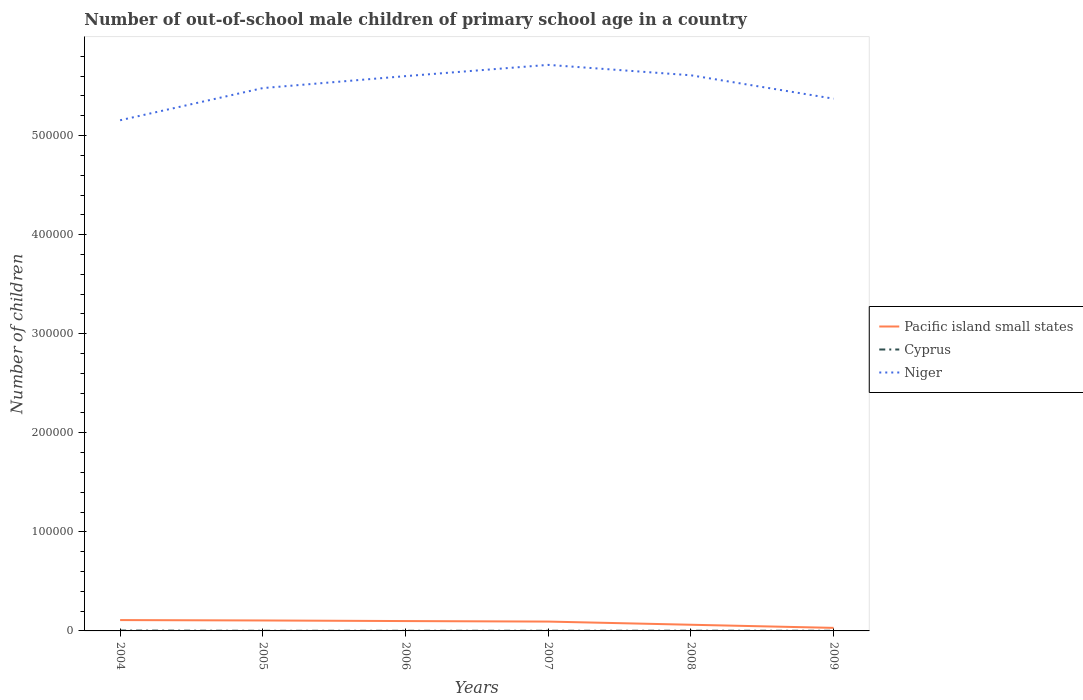Is the number of lines equal to the number of legend labels?
Offer a very short reply. Yes. Across all years, what is the maximum number of out-of-school male children in Pacific island small states?
Your answer should be very brief. 3078. What is the total number of out-of-school male children in Pacific island small states in the graph?
Offer a terse response. 3725. What is the difference between the highest and the second highest number of out-of-school male children in Pacific island small states?
Offer a terse response. 7874. How many years are there in the graph?
Your answer should be compact. 6. What is the difference between two consecutive major ticks on the Y-axis?
Offer a terse response. 1.00e+05. Are the values on the major ticks of Y-axis written in scientific E-notation?
Provide a short and direct response. No. Does the graph contain any zero values?
Keep it short and to the point. No. Does the graph contain grids?
Ensure brevity in your answer.  No. What is the title of the graph?
Make the answer very short. Number of out-of-school male children of primary school age in a country. What is the label or title of the Y-axis?
Offer a very short reply. Number of children. What is the Number of children of Pacific island small states in 2004?
Ensure brevity in your answer.  1.10e+04. What is the Number of children of Cyprus in 2004?
Your answer should be very brief. 380. What is the Number of children in Niger in 2004?
Make the answer very short. 5.16e+05. What is the Number of children in Pacific island small states in 2005?
Keep it short and to the point. 1.05e+04. What is the Number of children in Cyprus in 2005?
Keep it short and to the point. 130. What is the Number of children in Niger in 2005?
Keep it short and to the point. 5.48e+05. What is the Number of children in Pacific island small states in 2006?
Make the answer very short. 9948. What is the Number of children of Cyprus in 2006?
Provide a short and direct response. 142. What is the Number of children of Niger in 2006?
Provide a short and direct response. 5.60e+05. What is the Number of children of Pacific island small states in 2007?
Give a very brief answer. 9438. What is the Number of children in Cyprus in 2007?
Offer a very short reply. 163. What is the Number of children of Niger in 2007?
Your answer should be compact. 5.71e+05. What is the Number of children in Pacific island small states in 2008?
Your answer should be very brief. 6223. What is the Number of children of Cyprus in 2008?
Your answer should be compact. 212. What is the Number of children of Niger in 2008?
Your response must be concise. 5.61e+05. What is the Number of children of Pacific island small states in 2009?
Your response must be concise. 3078. What is the Number of children in Cyprus in 2009?
Ensure brevity in your answer.  155. What is the Number of children of Niger in 2009?
Your response must be concise. 5.37e+05. Across all years, what is the maximum Number of children in Pacific island small states?
Keep it short and to the point. 1.10e+04. Across all years, what is the maximum Number of children in Cyprus?
Give a very brief answer. 380. Across all years, what is the maximum Number of children in Niger?
Offer a very short reply. 5.71e+05. Across all years, what is the minimum Number of children of Pacific island small states?
Your answer should be compact. 3078. Across all years, what is the minimum Number of children in Cyprus?
Your answer should be very brief. 130. Across all years, what is the minimum Number of children of Niger?
Your response must be concise. 5.16e+05. What is the total Number of children in Pacific island small states in the graph?
Make the answer very short. 5.02e+04. What is the total Number of children in Cyprus in the graph?
Give a very brief answer. 1182. What is the total Number of children in Niger in the graph?
Keep it short and to the point. 3.29e+06. What is the difference between the Number of children in Pacific island small states in 2004 and that in 2005?
Keep it short and to the point. 407. What is the difference between the Number of children of Cyprus in 2004 and that in 2005?
Ensure brevity in your answer.  250. What is the difference between the Number of children in Niger in 2004 and that in 2005?
Your answer should be compact. -3.25e+04. What is the difference between the Number of children of Pacific island small states in 2004 and that in 2006?
Ensure brevity in your answer.  1004. What is the difference between the Number of children in Cyprus in 2004 and that in 2006?
Offer a terse response. 238. What is the difference between the Number of children of Niger in 2004 and that in 2006?
Provide a succinct answer. -4.45e+04. What is the difference between the Number of children of Pacific island small states in 2004 and that in 2007?
Ensure brevity in your answer.  1514. What is the difference between the Number of children of Cyprus in 2004 and that in 2007?
Provide a short and direct response. 217. What is the difference between the Number of children of Niger in 2004 and that in 2007?
Ensure brevity in your answer.  -5.59e+04. What is the difference between the Number of children of Pacific island small states in 2004 and that in 2008?
Provide a short and direct response. 4729. What is the difference between the Number of children in Cyprus in 2004 and that in 2008?
Your response must be concise. 168. What is the difference between the Number of children in Niger in 2004 and that in 2008?
Provide a succinct answer. -4.54e+04. What is the difference between the Number of children of Pacific island small states in 2004 and that in 2009?
Your response must be concise. 7874. What is the difference between the Number of children of Cyprus in 2004 and that in 2009?
Keep it short and to the point. 225. What is the difference between the Number of children of Niger in 2004 and that in 2009?
Make the answer very short. -2.18e+04. What is the difference between the Number of children in Pacific island small states in 2005 and that in 2006?
Keep it short and to the point. 597. What is the difference between the Number of children of Cyprus in 2005 and that in 2006?
Provide a succinct answer. -12. What is the difference between the Number of children in Niger in 2005 and that in 2006?
Make the answer very short. -1.21e+04. What is the difference between the Number of children of Pacific island small states in 2005 and that in 2007?
Offer a terse response. 1107. What is the difference between the Number of children of Cyprus in 2005 and that in 2007?
Give a very brief answer. -33. What is the difference between the Number of children in Niger in 2005 and that in 2007?
Your answer should be compact. -2.34e+04. What is the difference between the Number of children in Pacific island small states in 2005 and that in 2008?
Make the answer very short. 4322. What is the difference between the Number of children in Cyprus in 2005 and that in 2008?
Provide a short and direct response. -82. What is the difference between the Number of children of Niger in 2005 and that in 2008?
Offer a very short reply. -1.29e+04. What is the difference between the Number of children of Pacific island small states in 2005 and that in 2009?
Keep it short and to the point. 7467. What is the difference between the Number of children of Niger in 2005 and that in 2009?
Offer a very short reply. 1.07e+04. What is the difference between the Number of children in Pacific island small states in 2006 and that in 2007?
Your response must be concise. 510. What is the difference between the Number of children in Niger in 2006 and that in 2007?
Your answer should be compact. -1.14e+04. What is the difference between the Number of children of Pacific island small states in 2006 and that in 2008?
Offer a very short reply. 3725. What is the difference between the Number of children of Cyprus in 2006 and that in 2008?
Offer a very short reply. -70. What is the difference between the Number of children of Niger in 2006 and that in 2008?
Provide a succinct answer. -853. What is the difference between the Number of children of Pacific island small states in 2006 and that in 2009?
Your answer should be compact. 6870. What is the difference between the Number of children in Cyprus in 2006 and that in 2009?
Offer a very short reply. -13. What is the difference between the Number of children in Niger in 2006 and that in 2009?
Give a very brief answer. 2.28e+04. What is the difference between the Number of children in Pacific island small states in 2007 and that in 2008?
Provide a succinct answer. 3215. What is the difference between the Number of children of Cyprus in 2007 and that in 2008?
Keep it short and to the point. -49. What is the difference between the Number of children in Niger in 2007 and that in 2008?
Provide a succinct answer. 1.05e+04. What is the difference between the Number of children in Pacific island small states in 2007 and that in 2009?
Ensure brevity in your answer.  6360. What is the difference between the Number of children of Niger in 2007 and that in 2009?
Make the answer very short. 3.41e+04. What is the difference between the Number of children in Pacific island small states in 2008 and that in 2009?
Make the answer very short. 3145. What is the difference between the Number of children of Cyprus in 2008 and that in 2009?
Ensure brevity in your answer.  57. What is the difference between the Number of children of Niger in 2008 and that in 2009?
Give a very brief answer. 2.36e+04. What is the difference between the Number of children in Pacific island small states in 2004 and the Number of children in Cyprus in 2005?
Keep it short and to the point. 1.08e+04. What is the difference between the Number of children in Pacific island small states in 2004 and the Number of children in Niger in 2005?
Make the answer very short. -5.37e+05. What is the difference between the Number of children of Cyprus in 2004 and the Number of children of Niger in 2005?
Provide a short and direct response. -5.48e+05. What is the difference between the Number of children of Pacific island small states in 2004 and the Number of children of Cyprus in 2006?
Offer a very short reply. 1.08e+04. What is the difference between the Number of children of Pacific island small states in 2004 and the Number of children of Niger in 2006?
Your response must be concise. -5.49e+05. What is the difference between the Number of children of Cyprus in 2004 and the Number of children of Niger in 2006?
Your response must be concise. -5.60e+05. What is the difference between the Number of children in Pacific island small states in 2004 and the Number of children in Cyprus in 2007?
Your response must be concise. 1.08e+04. What is the difference between the Number of children in Pacific island small states in 2004 and the Number of children in Niger in 2007?
Your answer should be very brief. -5.60e+05. What is the difference between the Number of children of Cyprus in 2004 and the Number of children of Niger in 2007?
Give a very brief answer. -5.71e+05. What is the difference between the Number of children of Pacific island small states in 2004 and the Number of children of Cyprus in 2008?
Ensure brevity in your answer.  1.07e+04. What is the difference between the Number of children in Pacific island small states in 2004 and the Number of children in Niger in 2008?
Ensure brevity in your answer.  -5.50e+05. What is the difference between the Number of children of Cyprus in 2004 and the Number of children of Niger in 2008?
Keep it short and to the point. -5.61e+05. What is the difference between the Number of children in Pacific island small states in 2004 and the Number of children in Cyprus in 2009?
Your answer should be compact. 1.08e+04. What is the difference between the Number of children of Pacific island small states in 2004 and the Number of children of Niger in 2009?
Your answer should be compact. -5.26e+05. What is the difference between the Number of children in Cyprus in 2004 and the Number of children in Niger in 2009?
Your answer should be compact. -5.37e+05. What is the difference between the Number of children of Pacific island small states in 2005 and the Number of children of Cyprus in 2006?
Your answer should be very brief. 1.04e+04. What is the difference between the Number of children in Pacific island small states in 2005 and the Number of children in Niger in 2006?
Offer a terse response. -5.50e+05. What is the difference between the Number of children in Cyprus in 2005 and the Number of children in Niger in 2006?
Offer a very short reply. -5.60e+05. What is the difference between the Number of children of Pacific island small states in 2005 and the Number of children of Cyprus in 2007?
Give a very brief answer. 1.04e+04. What is the difference between the Number of children of Pacific island small states in 2005 and the Number of children of Niger in 2007?
Offer a terse response. -5.61e+05. What is the difference between the Number of children in Cyprus in 2005 and the Number of children in Niger in 2007?
Ensure brevity in your answer.  -5.71e+05. What is the difference between the Number of children in Pacific island small states in 2005 and the Number of children in Cyprus in 2008?
Give a very brief answer. 1.03e+04. What is the difference between the Number of children in Pacific island small states in 2005 and the Number of children in Niger in 2008?
Keep it short and to the point. -5.50e+05. What is the difference between the Number of children in Cyprus in 2005 and the Number of children in Niger in 2008?
Offer a very short reply. -5.61e+05. What is the difference between the Number of children in Pacific island small states in 2005 and the Number of children in Cyprus in 2009?
Offer a very short reply. 1.04e+04. What is the difference between the Number of children in Pacific island small states in 2005 and the Number of children in Niger in 2009?
Offer a terse response. -5.27e+05. What is the difference between the Number of children in Cyprus in 2005 and the Number of children in Niger in 2009?
Ensure brevity in your answer.  -5.37e+05. What is the difference between the Number of children in Pacific island small states in 2006 and the Number of children in Cyprus in 2007?
Offer a very short reply. 9785. What is the difference between the Number of children of Pacific island small states in 2006 and the Number of children of Niger in 2007?
Your response must be concise. -5.61e+05. What is the difference between the Number of children in Cyprus in 2006 and the Number of children in Niger in 2007?
Your response must be concise. -5.71e+05. What is the difference between the Number of children in Pacific island small states in 2006 and the Number of children in Cyprus in 2008?
Offer a very short reply. 9736. What is the difference between the Number of children in Pacific island small states in 2006 and the Number of children in Niger in 2008?
Your answer should be very brief. -5.51e+05. What is the difference between the Number of children of Cyprus in 2006 and the Number of children of Niger in 2008?
Your answer should be very brief. -5.61e+05. What is the difference between the Number of children in Pacific island small states in 2006 and the Number of children in Cyprus in 2009?
Your response must be concise. 9793. What is the difference between the Number of children of Pacific island small states in 2006 and the Number of children of Niger in 2009?
Offer a terse response. -5.27e+05. What is the difference between the Number of children of Cyprus in 2006 and the Number of children of Niger in 2009?
Your response must be concise. -5.37e+05. What is the difference between the Number of children of Pacific island small states in 2007 and the Number of children of Cyprus in 2008?
Keep it short and to the point. 9226. What is the difference between the Number of children in Pacific island small states in 2007 and the Number of children in Niger in 2008?
Provide a short and direct response. -5.51e+05. What is the difference between the Number of children of Cyprus in 2007 and the Number of children of Niger in 2008?
Your answer should be very brief. -5.61e+05. What is the difference between the Number of children of Pacific island small states in 2007 and the Number of children of Cyprus in 2009?
Offer a terse response. 9283. What is the difference between the Number of children of Pacific island small states in 2007 and the Number of children of Niger in 2009?
Provide a succinct answer. -5.28e+05. What is the difference between the Number of children in Cyprus in 2007 and the Number of children in Niger in 2009?
Ensure brevity in your answer.  -5.37e+05. What is the difference between the Number of children in Pacific island small states in 2008 and the Number of children in Cyprus in 2009?
Your answer should be very brief. 6068. What is the difference between the Number of children of Pacific island small states in 2008 and the Number of children of Niger in 2009?
Your answer should be compact. -5.31e+05. What is the difference between the Number of children of Cyprus in 2008 and the Number of children of Niger in 2009?
Offer a very short reply. -5.37e+05. What is the average Number of children in Pacific island small states per year?
Give a very brief answer. 8364. What is the average Number of children of Cyprus per year?
Your answer should be compact. 197. What is the average Number of children of Niger per year?
Your answer should be very brief. 5.49e+05. In the year 2004, what is the difference between the Number of children of Pacific island small states and Number of children of Cyprus?
Provide a succinct answer. 1.06e+04. In the year 2004, what is the difference between the Number of children of Pacific island small states and Number of children of Niger?
Give a very brief answer. -5.05e+05. In the year 2004, what is the difference between the Number of children in Cyprus and Number of children in Niger?
Provide a short and direct response. -5.15e+05. In the year 2005, what is the difference between the Number of children of Pacific island small states and Number of children of Cyprus?
Your response must be concise. 1.04e+04. In the year 2005, what is the difference between the Number of children of Pacific island small states and Number of children of Niger?
Provide a succinct answer. -5.37e+05. In the year 2005, what is the difference between the Number of children of Cyprus and Number of children of Niger?
Ensure brevity in your answer.  -5.48e+05. In the year 2006, what is the difference between the Number of children of Pacific island small states and Number of children of Cyprus?
Keep it short and to the point. 9806. In the year 2006, what is the difference between the Number of children in Pacific island small states and Number of children in Niger?
Give a very brief answer. -5.50e+05. In the year 2006, what is the difference between the Number of children of Cyprus and Number of children of Niger?
Your response must be concise. -5.60e+05. In the year 2007, what is the difference between the Number of children of Pacific island small states and Number of children of Cyprus?
Offer a terse response. 9275. In the year 2007, what is the difference between the Number of children of Pacific island small states and Number of children of Niger?
Provide a short and direct response. -5.62e+05. In the year 2007, what is the difference between the Number of children of Cyprus and Number of children of Niger?
Give a very brief answer. -5.71e+05. In the year 2008, what is the difference between the Number of children in Pacific island small states and Number of children in Cyprus?
Ensure brevity in your answer.  6011. In the year 2008, what is the difference between the Number of children of Pacific island small states and Number of children of Niger?
Your answer should be compact. -5.55e+05. In the year 2008, what is the difference between the Number of children of Cyprus and Number of children of Niger?
Your answer should be very brief. -5.61e+05. In the year 2009, what is the difference between the Number of children in Pacific island small states and Number of children in Cyprus?
Your response must be concise. 2923. In the year 2009, what is the difference between the Number of children of Pacific island small states and Number of children of Niger?
Make the answer very short. -5.34e+05. In the year 2009, what is the difference between the Number of children of Cyprus and Number of children of Niger?
Make the answer very short. -5.37e+05. What is the ratio of the Number of children in Pacific island small states in 2004 to that in 2005?
Give a very brief answer. 1.04. What is the ratio of the Number of children in Cyprus in 2004 to that in 2005?
Give a very brief answer. 2.92. What is the ratio of the Number of children in Niger in 2004 to that in 2005?
Give a very brief answer. 0.94. What is the ratio of the Number of children of Pacific island small states in 2004 to that in 2006?
Offer a very short reply. 1.1. What is the ratio of the Number of children in Cyprus in 2004 to that in 2006?
Ensure brevity in your answer.  2.68. What is the ratio of the Number of children of Niger in 2004 to that in 2006?
Make the answer very short. 0.92. What is the ratio of the Number of children of Pacific island small states in 2004 to that in 2007?
Give a very brief answer. 1.16. What is the ratio of the Number of children in Cyprus in 2004 to that in 2007?
Keep it short and to the point. 2.33. What is the ratio of the Number of children of Niger in 2004 to that in 2007?
Your response must be concise. 0.9. What is the ratio of the Number of children in Pacific island small states in 2004 to that in 2008?
Give a very brief answer. 1.76. What is the ratio of the Number of children of Cyprus in 2004 to that in 2008?
Your answer should be compact. 1.79. What is the ratio of the Number of children in Niger in 2004 to that in 2008?
Offer a terse response. 0.92. What is the ratio of the Number of children in Pacific island small states in 2004 to that in 2009?
Offer a very short reply. 3.56. What is the ratio of the Number of children in Cyprus in 2004 to that in 2009?
Ensure brevity in your answer.  2.45. What is the ratio of the Number of children in Niger in 2004 to that in 2009?
Your answer should be compact. 0.96. What is the ratio of the Number of children in Pacific island small states in 2005 to that in 2006?
Give a very brief answer. 1.06. What is the ratio of the Number of children in Cyprus in 2005 to that in 2006?
Your response must be concise. 0.92. What is the ratio of the Number of children of Niger in 2005 to that in 2006?
Your answer should be very brief. 0.98. What is the ratio of the Number of children in Pacific island small states in 2005 to that in 2007?
Offer a terse response. 1.12. What is the ratio of the Number of children of Cyprus in 2005 to that in 2007?
Keep it short and to the point. 0.8. What is the ratio of the Number of children in Niger in 2005 to that in 2007?
Offer a terse response. 0.96. What is the ratio of the Number of children of Pacific island small states in 2005 to that in 2008?
Offer a terse response. 1.69. What is the ratio of the Number of children of Cyprus in 2005 to that in 2008?
Your answer should be very brief. 0.61. What is the ratio of the Number of children of Niger in 2005 to that in 2008?
Your response must be concise. 0.98. What is the ratio of the Number of children of Pacific island small states in 2005 to that in 2009?
Your answer should be compact. 3.43. What is the ratio of the Number of children of Cyprus in 2005 to that in 2009?
Your answer should be very brief. 0.84. What is the ratio of the Number of children in Niger in 2005 to that in 2009?
Ensure brevity in your answer.  1.02. What is the ratio of the Number of children of Pacific island small states in 2006 to that in 2007?
Offer a terse response. 1.05. What is the ratio of the Number of children of Cyprus in 2006 to that in 2007?
Offer a very short reply. 0.87. What is the ratio of the Number of children of Niger in 2006 to that in 2007?
Your response must be concise. 0.98. What is the ratio of the Number of children of Pacific island small states in 2006 to that in 2008?
Provide a succinct answer. 1.6. What is the ratio of the Number of children of Cyprus in 2006 to that in 2008?
Offer a very short reply. 0.67. What is the ratio of the Number of children of Pacific island small states in 2006 to that in 2009?
Offer a very short reply. 3.23. What is the ratio of the Number of children in Cyprus in 2006 to that in 2009?
Your answer should be very brief. 0.92. What is the ratio of the Number of children in Niger in 2006 to that in 2009?
Offer a very short reply. 1.04. What is the ratio of the Number of children in Pacific island small states in 2007 to that in 2008?
Your answer should be compact. 1.52. What is the ratio of the Number of children of Cyprus in 2007 to that in 2008?
Provide a short and direct response. 0.77. What is the ratio of the Number of children of Niger in 2007 to that in 2008?
Provide a succinct answer. 1.02. What is the ratio of the Number of children of Pacific island small states in 2007 to that in 2009?
Your response must be concise. 3.07. What is the ratio of the Number of children of Cyprus in 2007 to that in 2009?
Give a very brief answer. 1.05. What is the ratio of the Number of children of Niger in 2007 to that in 2009?
Your answer should be very brief. 1.06. What is the ratio of the Number of children in Pacific island small states in 2008 to that in 2009?
Offer a very short reply. 2.02. What is the ratio of the Number of children of Cyprus in 2008 to that in 2009?
Keep it short and to the point. 1.37. What is the ratio of the Number of children in Niger in 2008 to that in 2009?
Your response must be concise. 1.04. What is the difference between the highest and the second highest Number of children in Pacific island small states?
Offer a terse response. 407. What is the difference between the highest and the second highest Number of children in Cyprus?
Ensure brevity in your answer.  168. What is the difference between the highest and the second highest Number of children in Niger?
Your response must be concise. 1.05e+04. What is the difference between the highest and the lowest Number of children in Pacific island small states?
Your answer should be compact. 7874. What is the difference between the highest and the lowest Number of children of Cyprus?
Offer a terse response. 250. What is the difference between the highest and the lowest Number of children in Niger?
Make the answer very short. 5.59e+04. 